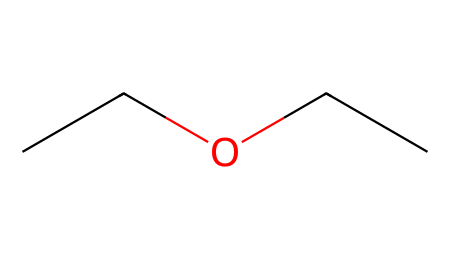What is the molecular formula of diethyl ether? The SMILES representation "CCOCC" indicates there are two ethyl groups (C2H5) connected by an oxygen atom (O), leading to the molecular formula C4H10O.
Answer: C4H10O How many carbon atoms are present in diethyl ether? Counting from the SMILES representation "CCOCC," there are four carbon atoms that make up the two ethyl groups.
Answer: 4 How many hydrogen atoms does diethyl ether have? Given the molecular formula C4H10O derived from the SMILES, there are 10 hydrogen atoms present in diethyl ether.
Answer: 10 What functional group is present in diethyl ether? The structure shows an oxygen atom connected between two carbon chains, characteristic of ethers, namely the -O- bond.
Answer: ether What type of solvent is diethyl ether classified as? Diethyl ether is known as a solvent due to its ability to dissolve various organic compounds; it is classified as an aprotic solvent.
Answer: aprotic Is diethyl ether flammable? Due to its low flash point and volatility, diethyl ether is highly flammable, making it a fire hazard when exposed to open flames or sparks.
Answer: flammable What property makes diethyl ether suitable for cleaning purposes? Diethyl ether's ability to dissolve a wide range of organic substances and its low polarity allows it to effectively clean oils and fats, making it a useful cleaning agent.
Answer: cleaning agent 